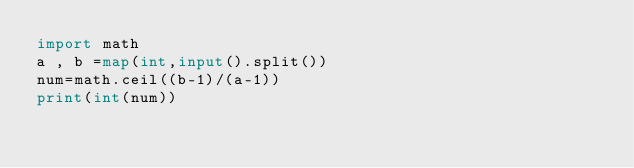Convert code to text. <code><loc_0><loc_0><loc_500><loc_500><_Python_>import math
a , b =map(int,input().split())
num=math.ceil((b-1)/(a-1))
print(int(num))</code> 